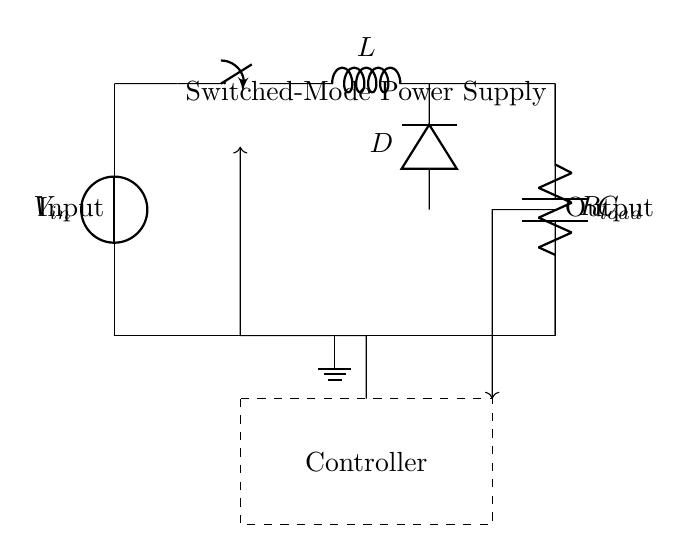What is the input component of the circuit? The circuit diagram shows a voltage source labeled V_in at the input, which provides the initial power to the system.
Answer: Voltage source What is the function of the switch in the circuit? The switch controls the connection between the voltage source and the inductor, allowing or interrupting the current flow, which is essential for switched-mode operation.
Answer: To control current flow Which component is responsible for storing energy in the circuit? The inductor (L) stores energy in the magnetic field when current passes through it, playing a critical role in the energy conversion process in a switched-mode power supply.
Answer: Inductor What does the feedback loop indicate in the circuit? The feedback loop relays information from the output back to the controller, allowing it to adjust the operation of the switch based on the output conditions to maintain desired performance.
Answer: Regulates output What is the purpose of the controller in this circuit? The controller manages the operation of the switch and receives feedback to ensure that the output voltage remains stable and within specifications by adjusting the duty cycle of the switch.
Answer: To manage switching What type of regulator is depicted in this circuit? The circuit represents a switched-mode power supply regulator, which is known for its high efficiency, especially in office equipment, by converting voltage levels while minimizing energy loss.
Answer: Switched-mode power supply 